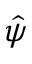Convert formula to latex. <formula><loc_0><loc_0><loc_500><loc_500>\hat { \psi }</formula> 